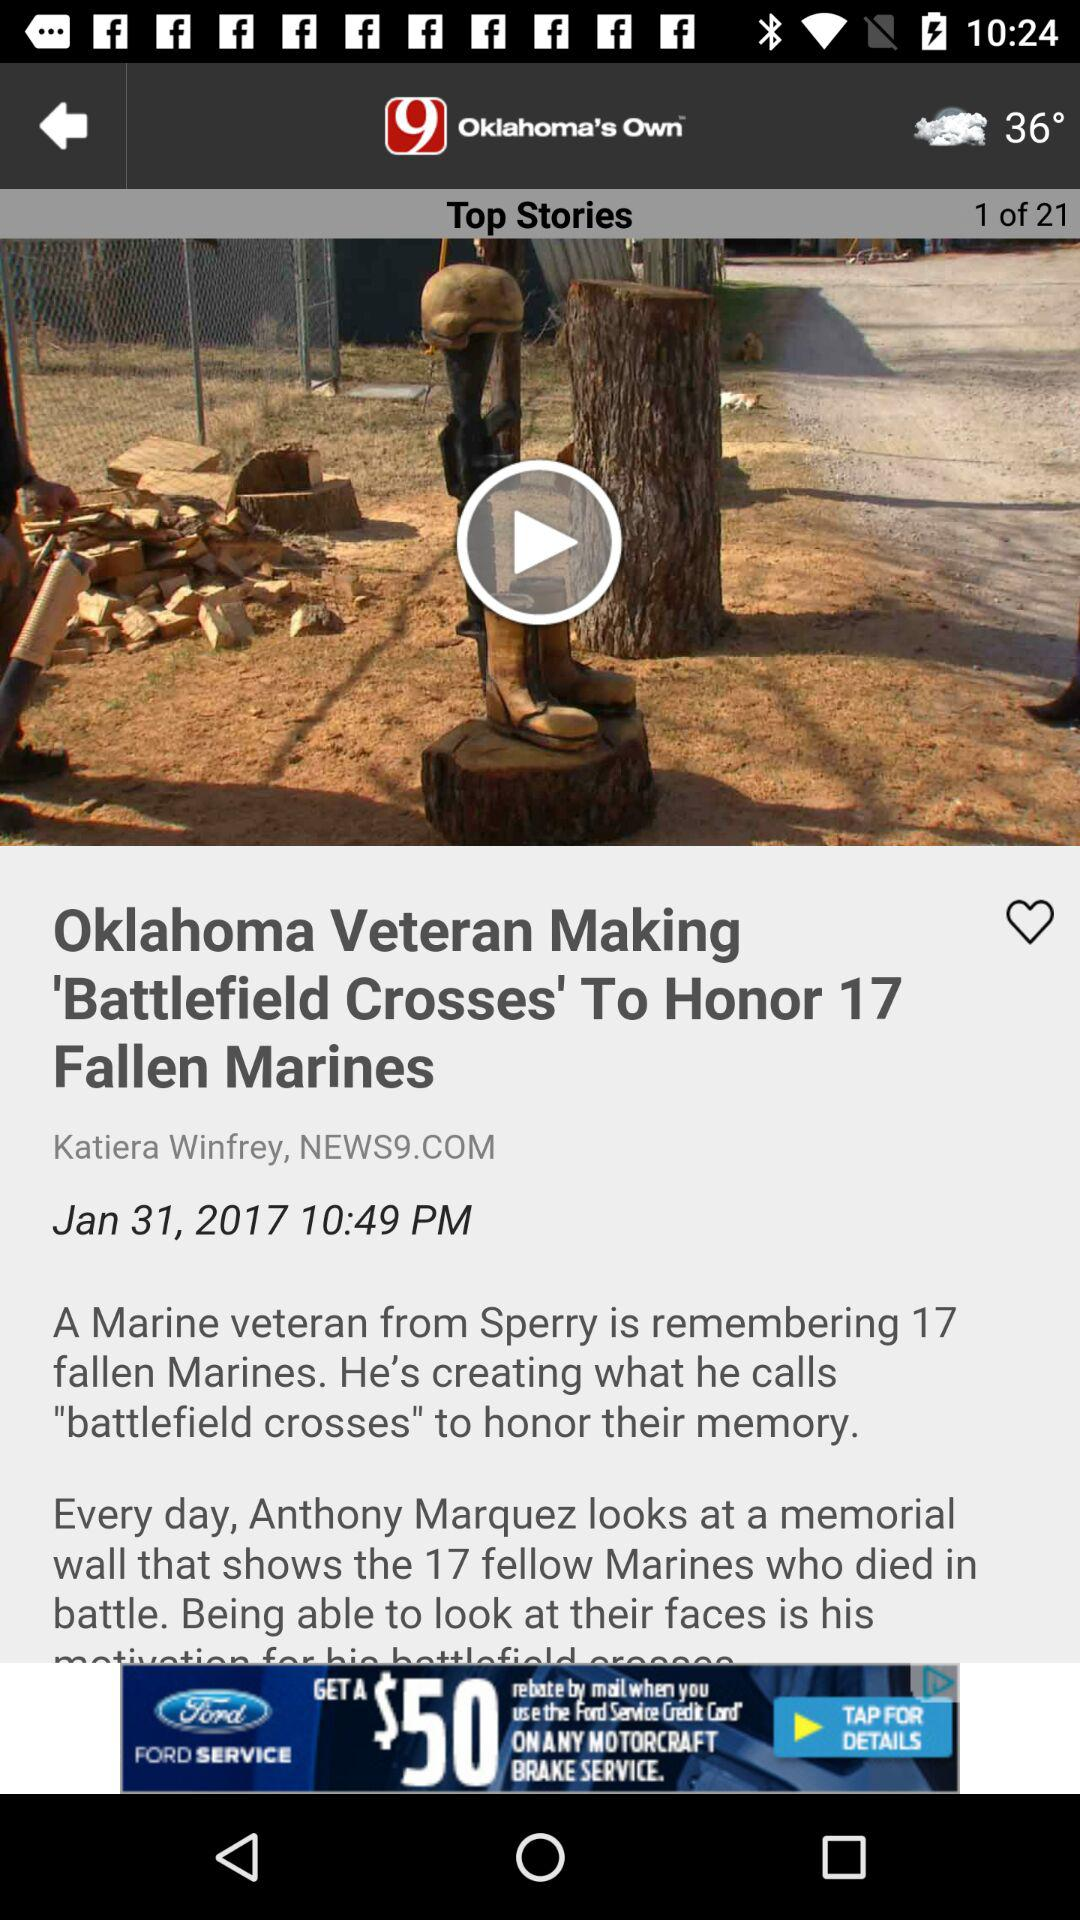What is the published date of the article "Oklahoma Veteran Making 'Battlefield Crosses' To Honor 17 Fallen Marines"? The date is January 31, 2017. 